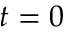<formula> <loc_0><loc_0><loc_500><loc_500>t = 0</formula> 